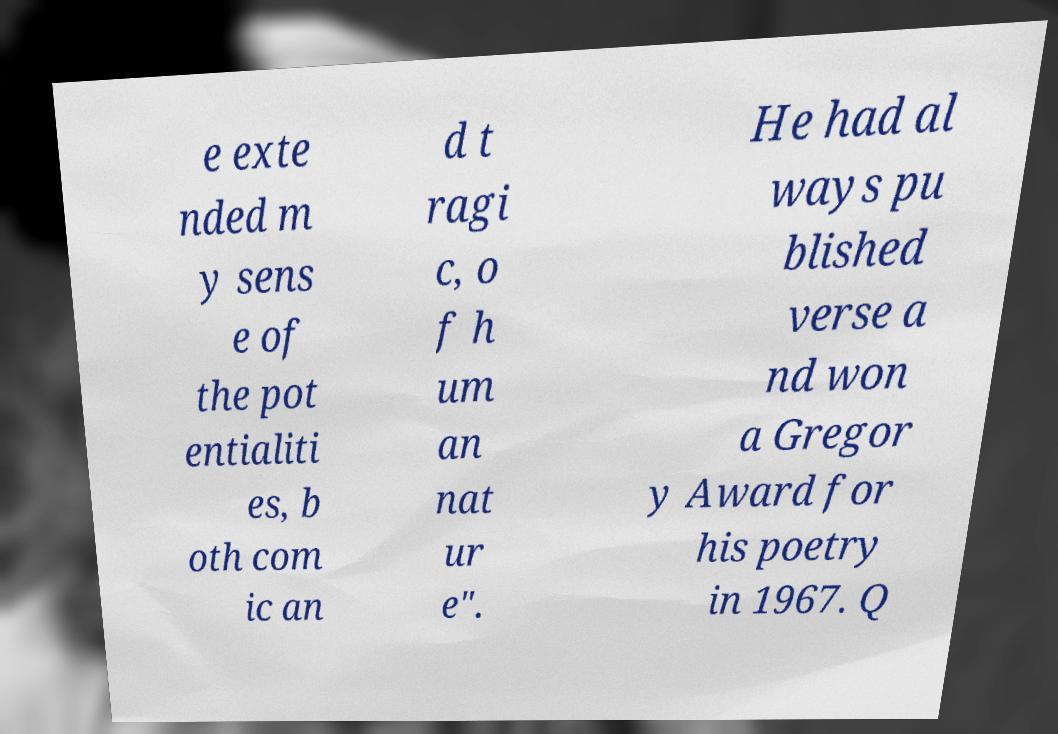I need the written content from this picture converted into text. Can you do that? e exte nded m y sens e of the pot entialiti es, b oth com ic an d t ragi c, o f h um an nat ur e". He had al ways pu blished verse a nd won a Gregor y Award for his poetry in 1967. Q 